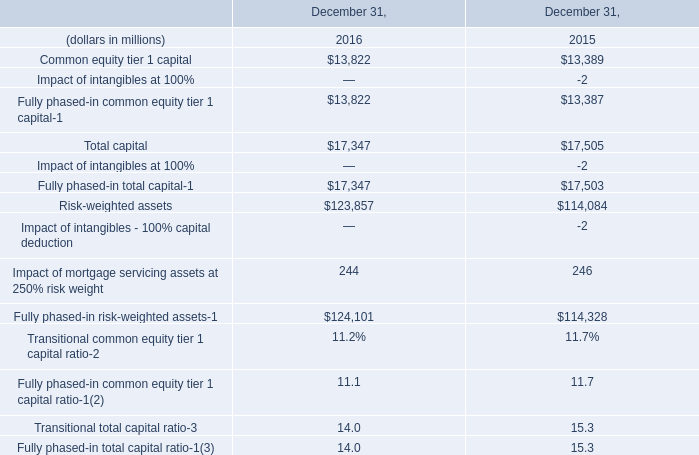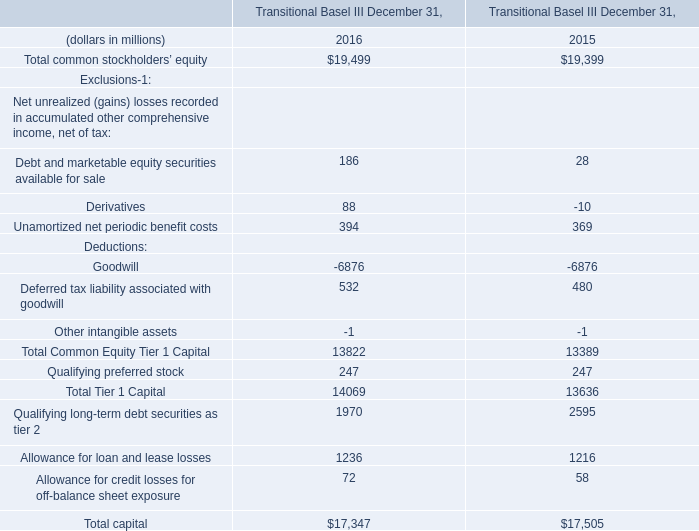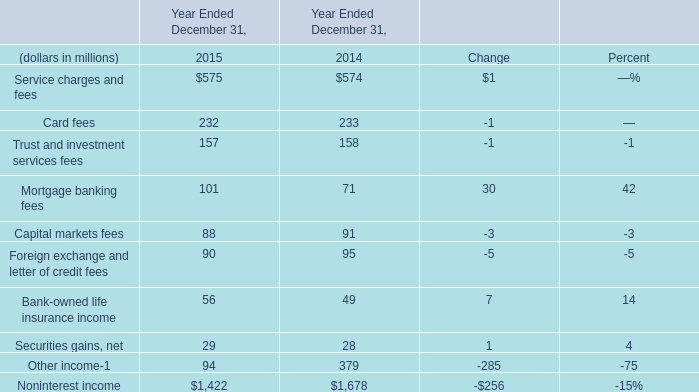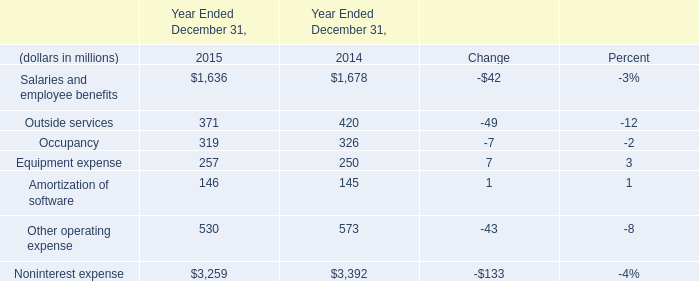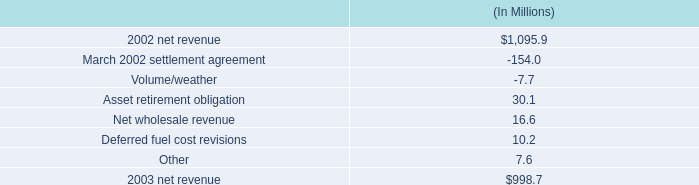In what year the Mortgage banking fees is greater than 100? 
Answer: 2015. 